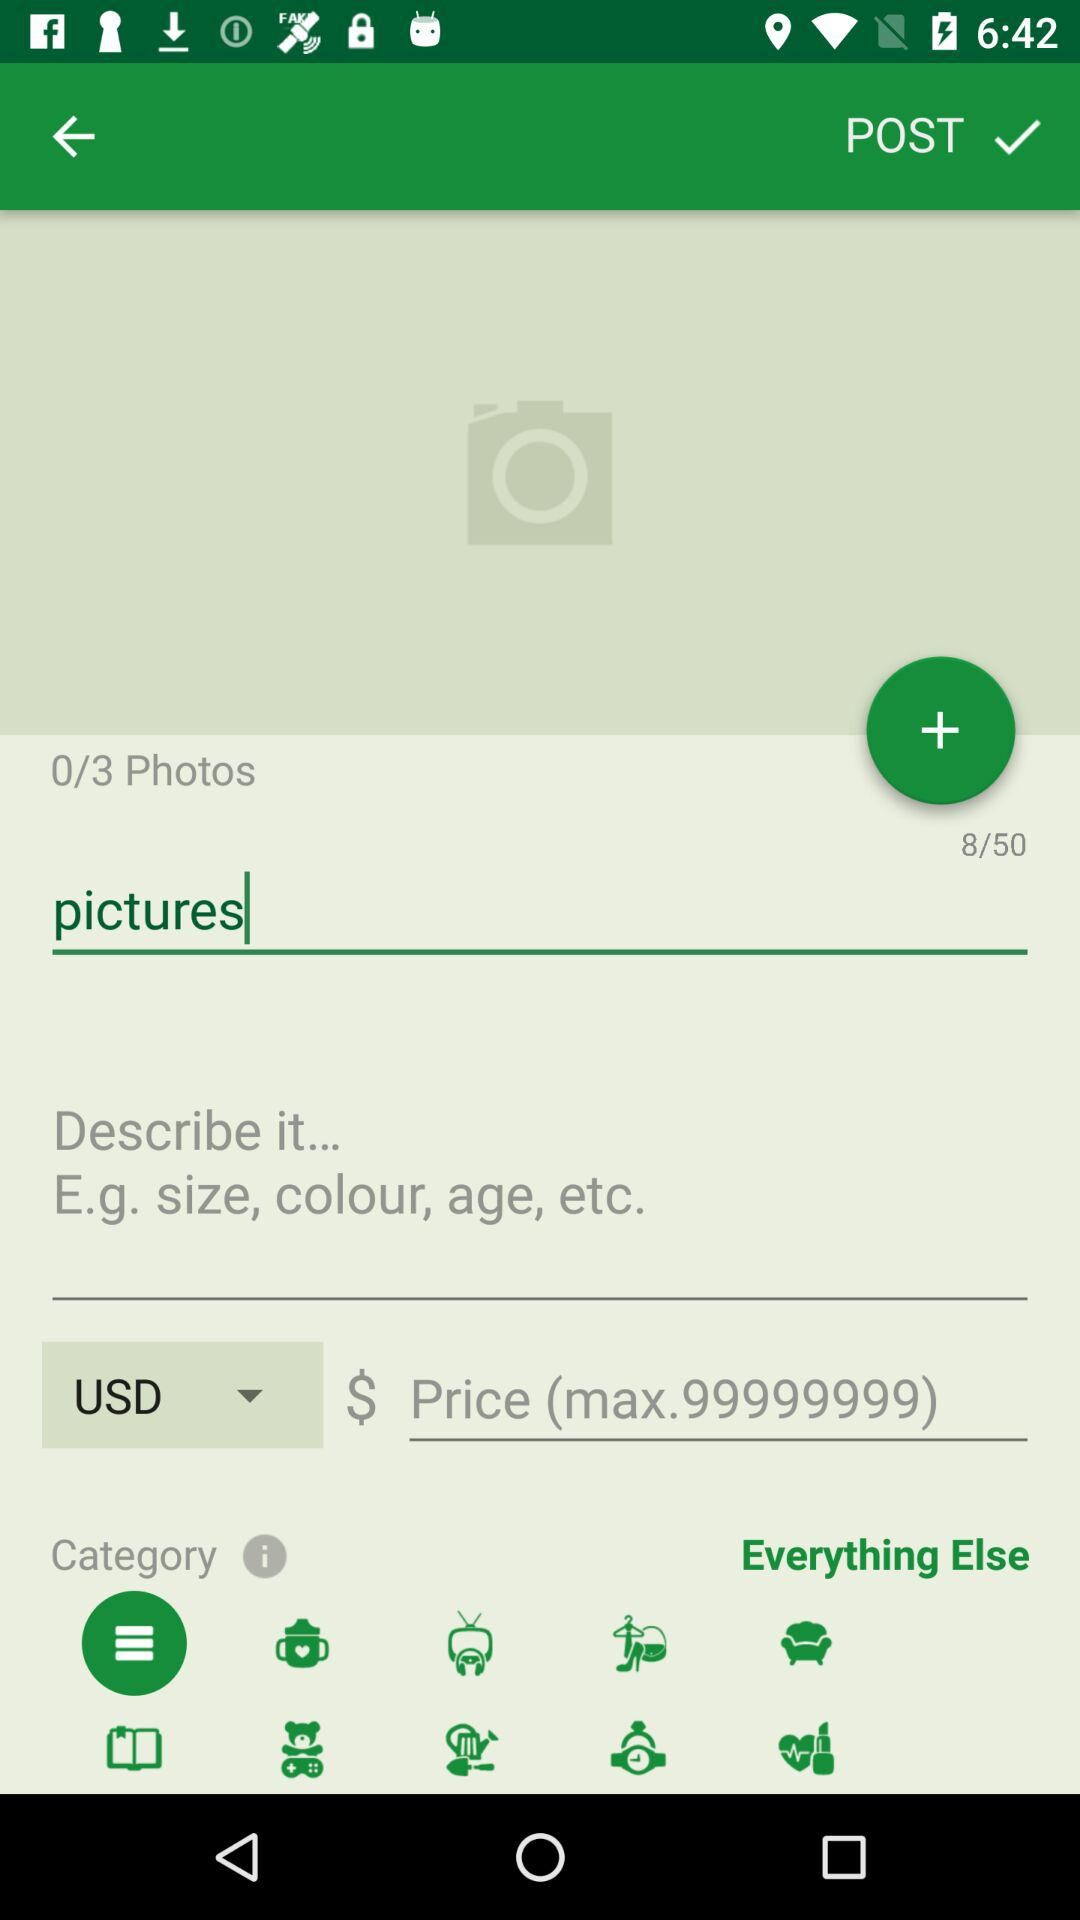What is the count of photos? The count of photos is 0. 